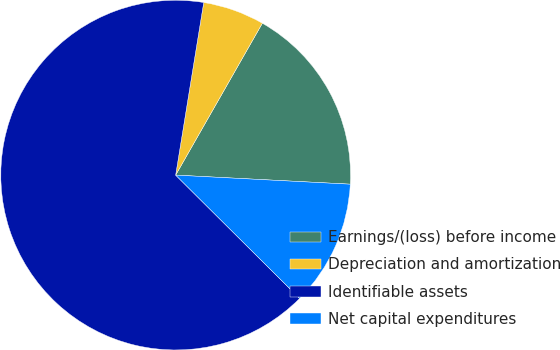Convert chart. <chart><loc_0><loc_0><loc_500><loc_500><pie_chart><fcel>Earnings/(loss) before income<fcel>Depreciation and amortization<fcel>Identifiable assets<fcel>Net capital expenditures<nl><fcel>17.57%<fcel>5.69%<fcel>65.1%<fcel>11.63%<nl></chart> 